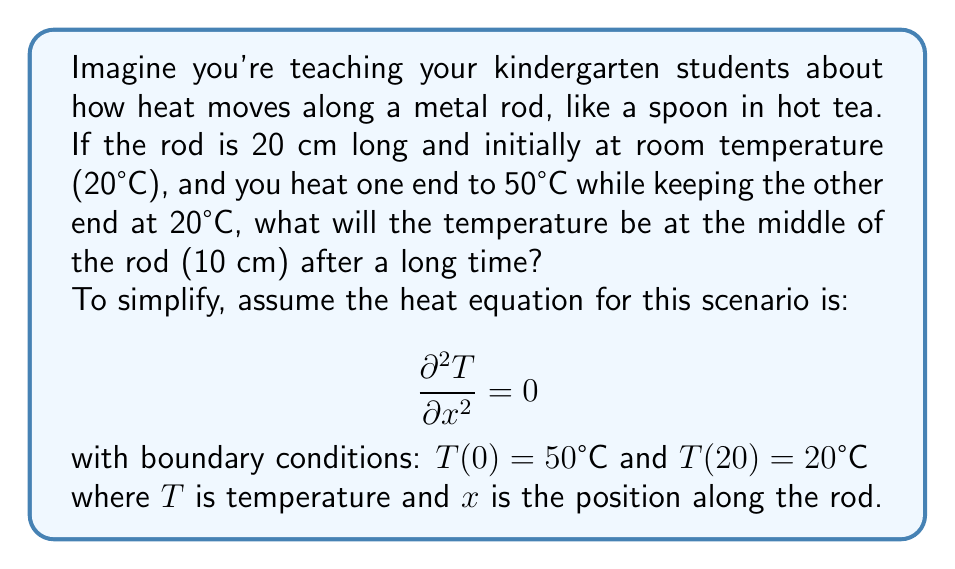What is the answer to this math problem? Let's break this down into simple steps:

1) The steady-state heat equation $\frac{\partial^2 T}{\partial x^2} = 0$ has a general solution of the form:

   $$ T(x) = ax + b $$

   where $a$ and $b$ are constants we need to find.

2) We can use the boundary conditions to find $a$ and $b$:

   At $x = 0$: $T(0) = 50°C = b$
   At $x = 20$: $T(20) = 20°C = 20a + 50$

3) From the second condition:
   $$ 20a + 50 = 20 $$
   $$ 20a = -30 $$
   $$ a = -1.5 $$

4) So our solution is:
   $$ T(x) = -1.5x + 50 $$

5) To find the temperature at the middle (10 cm), we substitute $x = 10$:
   $$ T(10) = -1.5(10) + 50 = -15 + 50 = 35°C $$

This linear solution makes sense for kindergarten teachers as it's like a straight line connecting the hot end (50°C) to the cool end (20°C), with the middle being exactly halfway between these temperatures.
Answer: The temperature at the middle of the rod (10 cm) after a long time will be 35°C. 